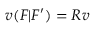<formula> <loc_0><loc_0><loc_500><loc_500>v ( F | F ^ { \prime } ) = R v</formula> 